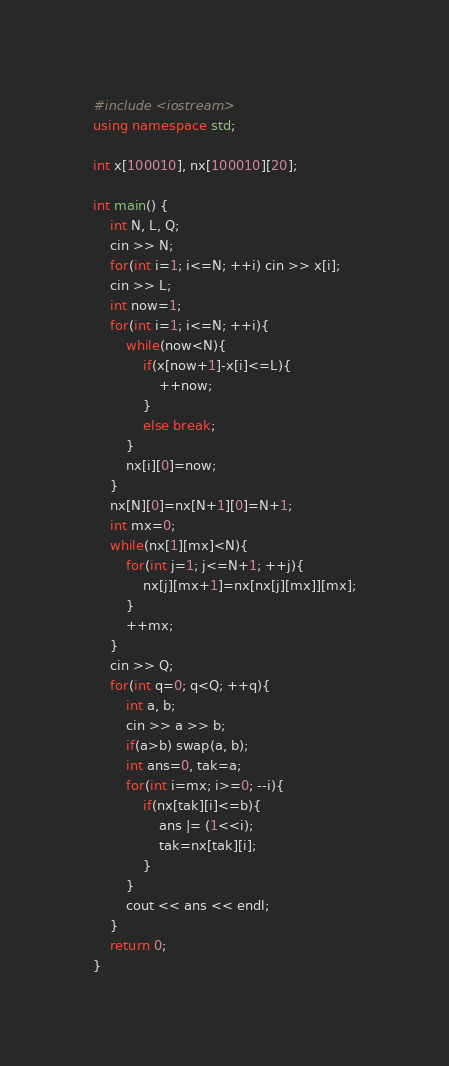<code> <loc_0><loc_0><loc_500><loc_500><_C++_>#include <iostream>
using namespace std;

int x[100010], nx[100010][20];

int main() {
	int N, L, Q;
	cin >> N;
	for(int i=1; i<=N; ++i) cin >> x[i];
	cin >> L;
	int now=1;
	for(int i=1; i<=N; ++i){
		while(now<N){
			if(x[now+1]-x[i]<=L){
				++now;
			}
			else break;
		}
		nx[i][0]=now;
	}
	nx[N][0]=nx[N+1][0]=N+1;
	int mx=0;
	while(nx[1][mx]<N){
		for(int j=1; j<=N+1; ++j){
			nx[j][mx+1]=nx[nx[j][mx]][mx];
		}
		++mx;
	}
	cin >> Q;
	for(int q=0; q<Q; ++q){
		int a, b;
		cin >> a >> b;
		if(a>b) swap(a, b);
		int ans=0, tak=a;
		for(int i=mx; i>=0; --i){
			if(nx[tak][i]<=b){
				ans |= (1<<i);
				tak=nx[tak][i];
			}
		}
		cout << ans << endl;
	}
	return 0;
}</code> 